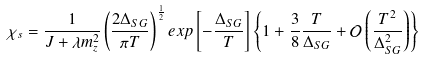Convert formula to latex. <formula><loc_0><loc_0><loc_500><loc_500>\chi _ { s } = \frac { 1 } { J + \lambda m _ { z } ^ { 2 } } \left ( \frac { 2 \Delta _ { S G } } { \pi T } \right ) ^ { \frac { 1 } { 2 } } e x p \left [ - \frac { \Delta _ { S G } } { T } \right ] \left \{ 1 + \frac { 3 } { 8 } \frac { T } { \Delta _ { S G } } + \mathcal { O } \left ( \frac { T ^ { 2 } } { \Delta _ { S G } ^ { 2 } } \right ) \right \}</formula> 